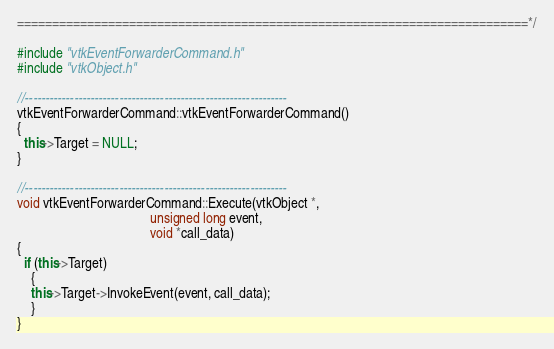<code> <loc_0><loc_0><loc_500><loc_500><_C++_>=========================================================================*/

#include "vtkEventForwarderCommand.h"
#include "vtkObject.h"

//----------------------------------------------------------------
vtkEventForwarderCommand::vtkEventForwarderCommand() 
{ 
  this->Target = NULL;
}

//----------------------------------------------------------------
void vtkEventForwarderCommand::Execute(vtkObject *, 
                                       unsigned long event,
                                       void *call_data)
{
  if (this->Target)
    {
    this->Target->InvokeEvent(event, call_data);
    }
}

</code> 